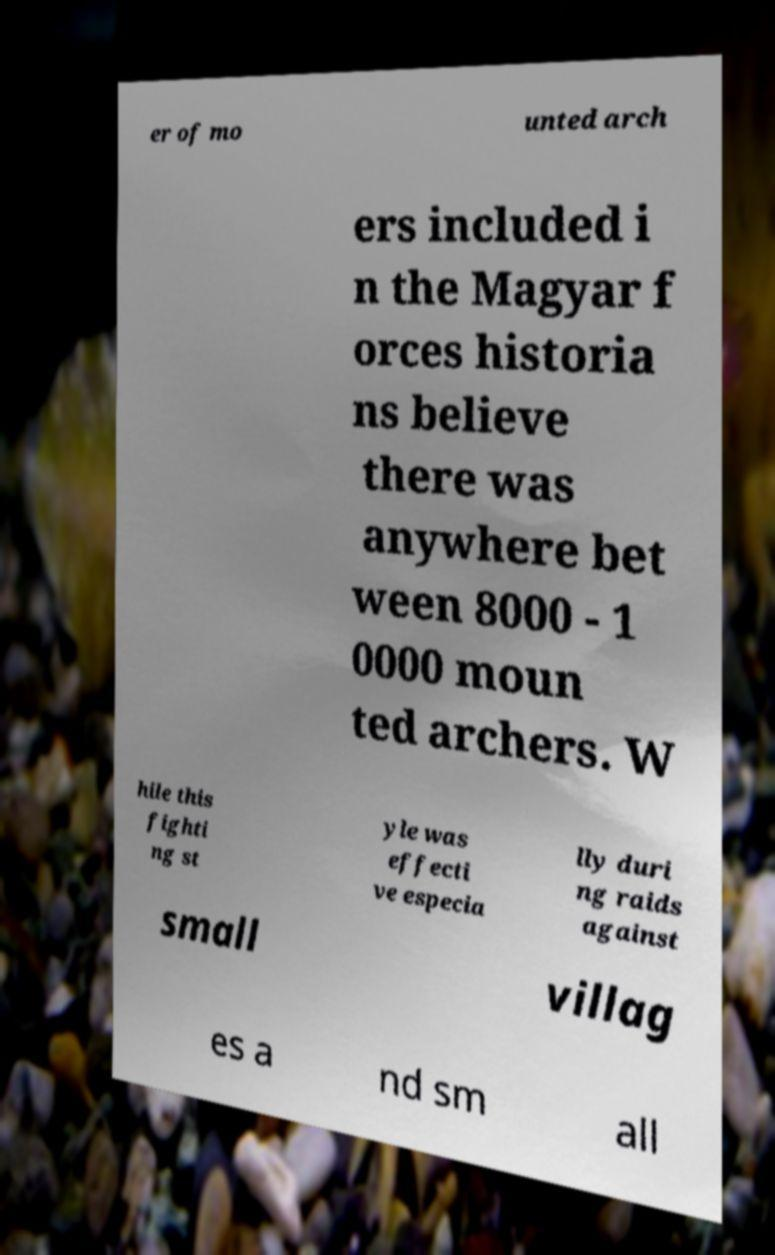There's text embedded in this image that I need extracted. Can you transcribe it verbatim? er of mo unted arch ers included i n the Magyar f orces historia ns believe there was anywhere bet ween 8000 - 1 0000 moun ted archers. W hile this fighti ng st yle was effecti ve especia lly duri ng raids against small villag es a nd sm all 